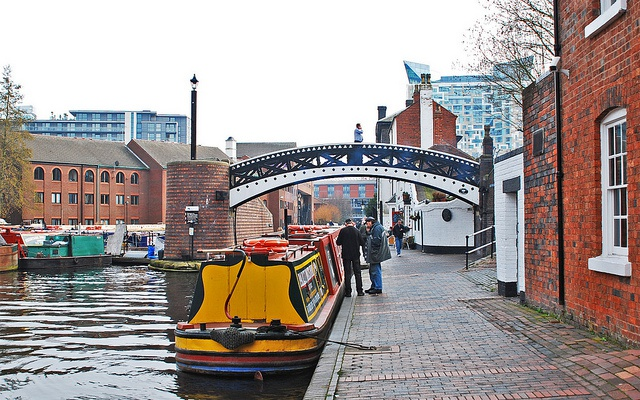Describe the objects in this image and their specific colors. I can see boat in white, black, orange, and maroon tones, boat in white, black, teal, and gray tones, people in white, black, gray, darkgray, and lightgray tones, people in white, black, navy, blue, and gray tones, and boat in white, brown, tan, and black tones in this image. 